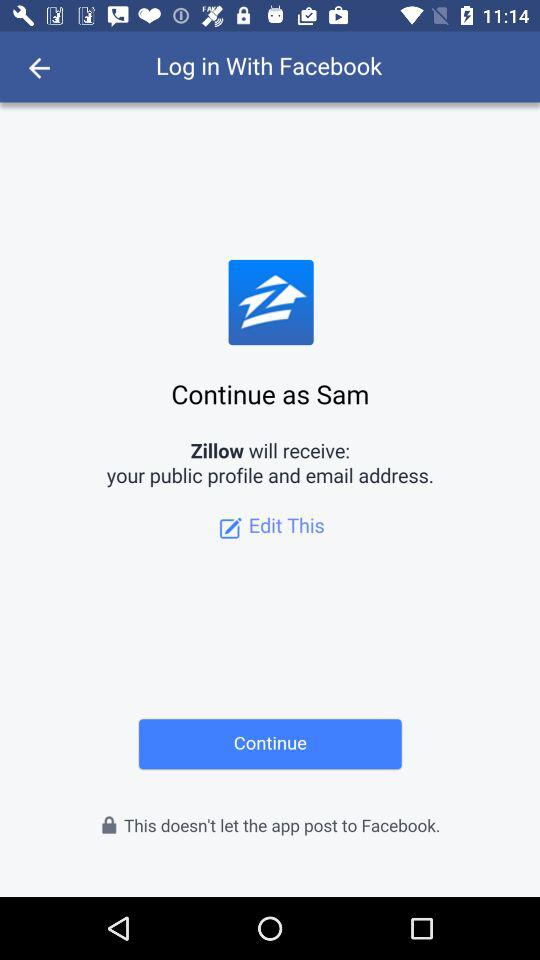Which app is used to log in? The app is "Facebook". 